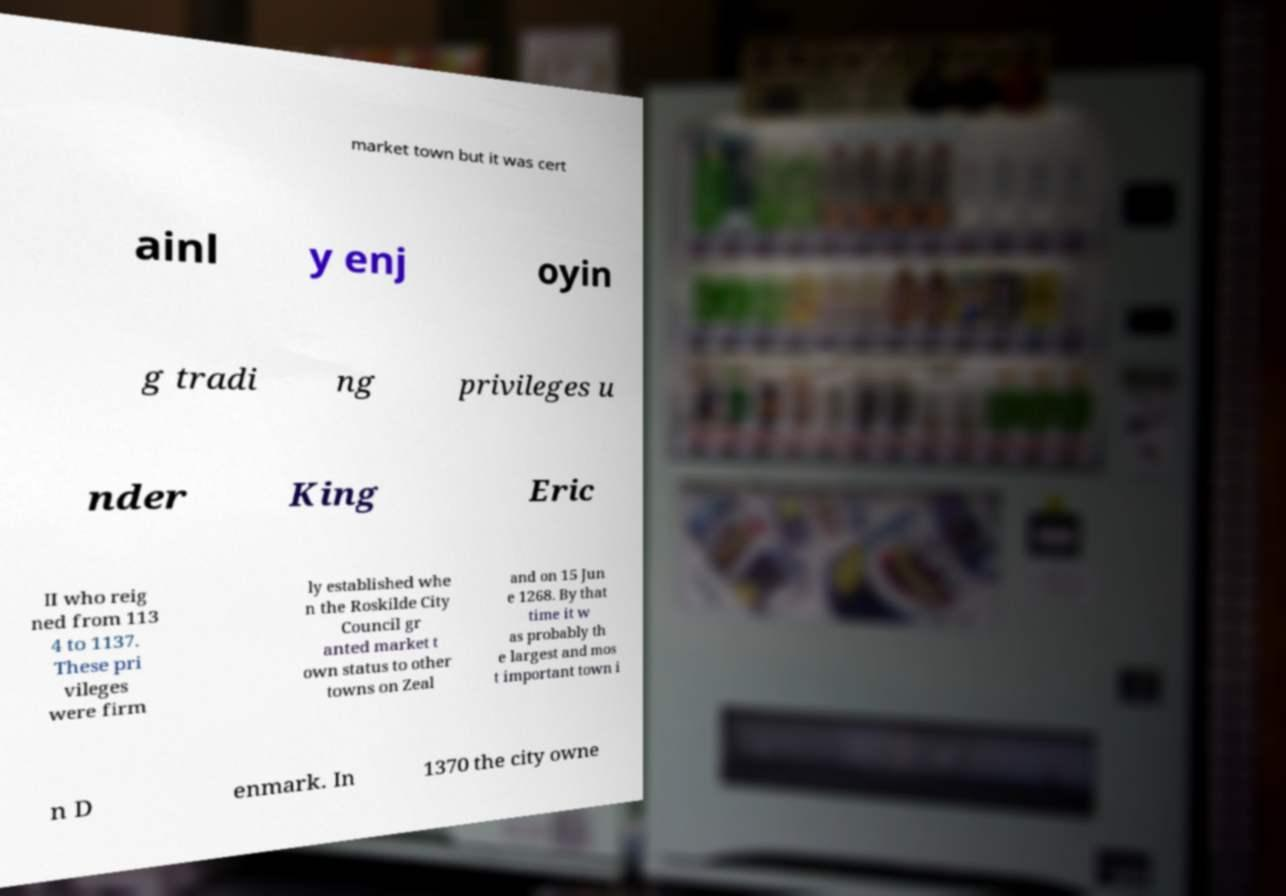Can you accurately transcribe the text from the provided image for me? market town but it was cert ainl y enj oyin g tradi ng privileges u nder King Eric II who reig ned from 113 4 to 1137. These pri vileges were firm ly established whe n the Roskilde City Council gr anted market t own status to other towns on Zeal and on 15 Jun e 1268. By that time it w as probably th e largest and mos t important town i n D enmark. In 1370 the city owne 